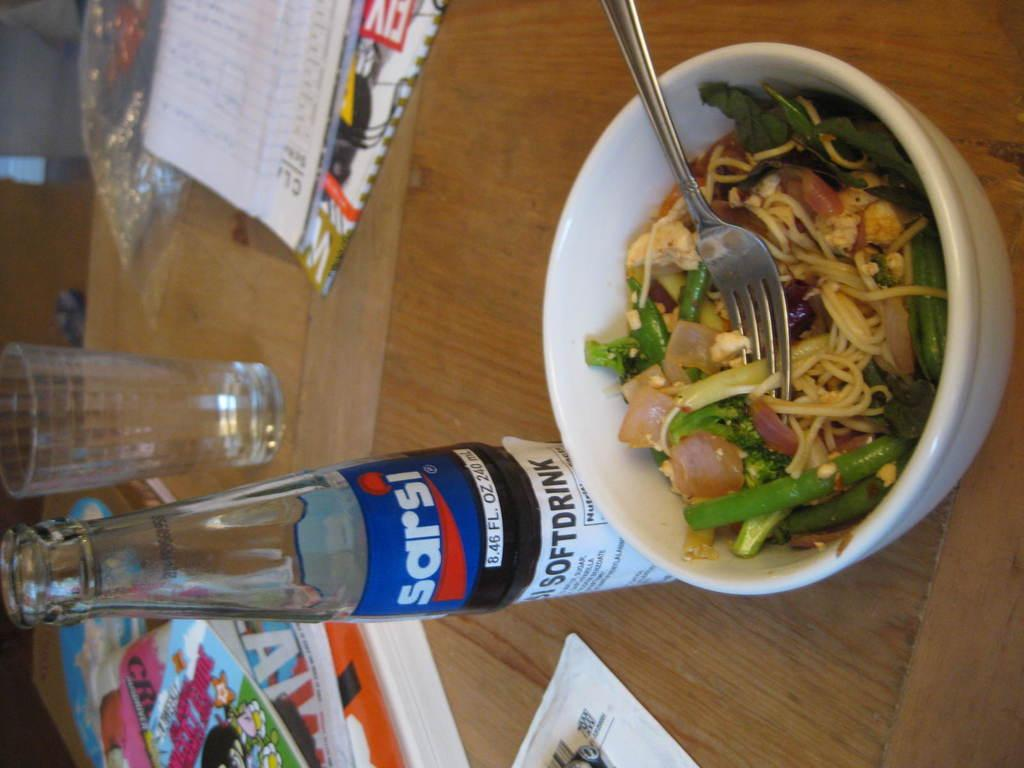<image>
Render a clear and concise summary of the photo. A bottle of Sarsi is placed next to a bowl of food. 